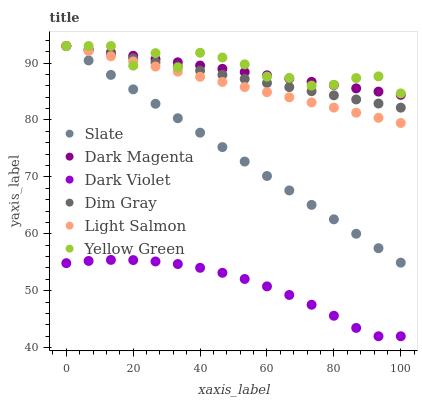Does Dark Violet have the minimum area under the curve?
Answer yes or no. Yes. Does Yellow Green have the maximum area under the curve?
Answer yes or no. Yes. Does Dim Gray have the minimum area under the curve?
Answer yes or no. No. Does Dim Gray have the maximum area under the curve?
Answer yes or no. No. Is Slate the smoothest?
Answer yes or no. Yes. Is Yellow Green the roughest?
Answer yes or no. Yes. Is Dim Gray the smoothest?
Answer yes or no. No. Is Dim Gray the roughest?
Answer yes or no. No. Does Dark Violet have the lowest value?
Answer yes or no. Yes. Does Dim Gray have the lowest value?
Answer yes or no. No. Does Dark Magenta have the highest value?
Answer yes or no. Yes. Does Dark Violet have the highest value?
Answer yes or no. No. Is Dark Violet less than Slate?
Answer yes or no. Yes. Is Dark Magenta greater than Dark Violet?
Answer yes or no. Yes. Does Light Salmon intersect Dark Magenta?
Answer yes or no. Yes. Is Light Salmon less than Dark Magenta?
Answer yes or no. No. Is Light Salmon greater than Dark Magenta?
Answer yes or no. No. Does Dark Violet intersect Slate?
Answer yes or no. No. 